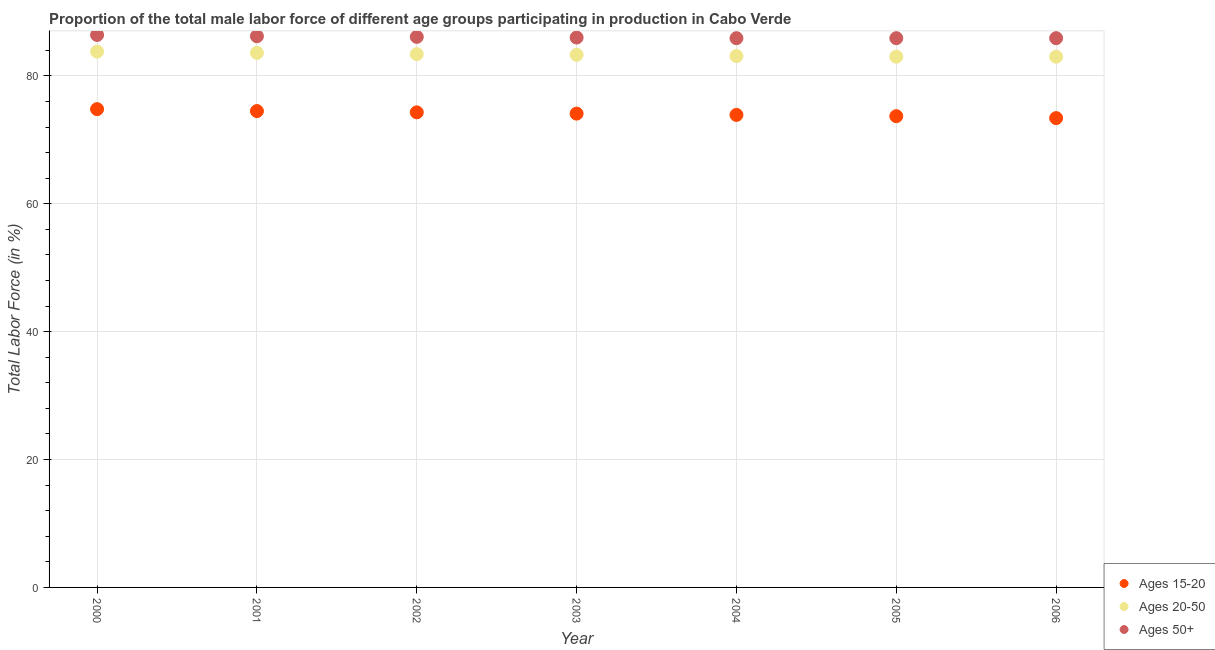What is the percentage of male labor force within the age group 20-50 in 2002?
Your answer should be very brief. 83.4. Across all years, what is the maximum percentage of male labor force above age 50?
Make the answer very short. 86.4. Across all years, what is the minimum percentage of male labor force within the age group 15-20?
Provide a succinct answer. 73.4. In which year was the percentage of male labor force above age 50 maximum?
Provide a short and direct response. 2000. In which year was the percentage of male labor force within the age group 20-50 minimum?
Offer a terse response. 2005. What is the total percentage of male labor force within the age group 20-50 in the graph?
Provide a short and direct response. 583.2. What is the difference between the percentage of male labor force above age 50 in 2003 and that in 2004?
Your response must be concise. 0.1. What is the difference between the percentage of male labor force above age 50 in 2003 and the percentage of male labor force within the age group 20-50 in 2004?
Give a very brief answer. 2.9. What is the average percentage of male labor force within the age group 20-50 per year?
Provide a succinct answer. 83.31. In the year 2006, what is the difference between the percentage of male labor force within the age group 15-20 and percentage of male labor force within the age group 20-50?
Offer a very short reply. -9.6. What is the ratio of the percentage of male labor force within the age group 15-20 in 2001 to that in 2004?
Your answer should be very brief. 1.01. Is the percentage of male labor force above age 50 in 2003 less than that in 2006?
Provide a succinct answer. No. Is the difference between the percentage of male labor force within the age group 15-20 in 2002 and 2003 greater than the difference between the percentage of male labor force within the age group 20-50 in 2002 and 2003?
Provide a short and direct response. Yes. What is the difference between the highest and the second highest percentage of male labor force within the age group 20-50?
Offer a terse response. 0.2. What is the difference between the highest and the lowest percentage of male labor force within the age group 15-20?
Provide a short and direct response. 1.4. Is the sum of the percentage of male labor force above age 50 in 2001 and 2004 greater than the maximum percentage of male labor force within the age group 20-50 across all years?
Your answer should be very brief. Yes. Is it the case that in every year, the sum of the percentage of male labor force within the age group 15-20 and percentage of male labor force within the age group 20-50 is greater than the percentage of male labor force above age 50?
Your response must be concise. Yes. How many dotlines are there?
Give a very brief answer. 3. How many years are there in the graph?
Provide a short and direct response. 7. What is the difference between two consecutive major ticks on the Y-axis?
Your answer should be very brief. 20. Where does the legend appear in the graph?
Keep it short and to the point. Bottom right. How are the legend labels stacked?
Provide a succinct answer. Vertical. What is the title of the graph?
Give a very brief answer. Proportion of the total male labor force of different age groups participating in production in Cabo Verde. Does "Solid fuel" appear as one of the legend labels in the graph?
Offer a terse response. No. What is the label or title of the Y-axis?
Provide a succinct answer. Total Labor Force (in %). What is the Total Labor Force (in %) of Ages 15-20 in 2000?
Ensure brevity in your answer.  74.8. What is the Total Labor Force (in %) in Ages 20-50 in 2000?
Provide a succinct answer. 83.8. What is the Total Labor Force (in %) in Ages 50+ in 2000?
Make the answer very short. 86.4. What is the Total Labor Force (in %) in Ages 15-20 in 2001?
Your answer should be very brief. 74.5. What is the Total Labor Force (in %) of Ages 20-50 in 2001?
Give a very brief answer. 83.6. What is the Total Labor Force (in %) of Ages 50+ in 2001?
Your response must be concise. 86.2. What is the Total Labor Force (in %) in Ages 15-20 in 2002?
Keep it short and to the point. 74.3. What is the Total Labor Force (in %) in Ages 20-50 in 2002?
Offer a terse response. 83.4. What is the Total Labor Force (in %) of Ages 50+ in 2002?
Provide a succinct answer. 86.1. What is the Total Labor Force (in %) in Ages 15-20 in 2003?
Give a very brief answer. 74.1. What is the Total Labor Force (in %) of Ages 20-50 in 2003?
Give a very brief answer. 83.3. What is the Total Labor Force (in %) in Ages 15-20 in 2004?
Offer a very short reply. 73.9. What is the Total Labor Force (in %) of Ages 20-50 in 2004?
Your answer should be compact. 83.1. What is the Total Labor Force (in %) of Ages 50+ in 2004?
Your answer should be very brief. 85.9. What is the Total Labor Force (in %) in Ages 15-20 in 2005?
Make the answer very short. 73.7. What is the Total Labor Force (in %) of Ages 20-50 in 2005?
Your answer should be compact. 83. What is the Total Labor Force (in %) of Ages 50+ in 2005?
Keep it short and to the point. 85.9. What is the Total Labor Force (in %) of Ages 15-20 in 2006?
Provide a succinct answer. 73.4. What is the Total Labor Force (in %) of Ages 20-50 in 2006?
Provide a succinct answer. 83. What is the Total Labor Force (in %) of Ages 50+ in 2006?
Your answer should be very brief. 85.9. Across all years, what is the maximum Total Labor Force (in %) of Ages 15-20?
Your response must be concise. 74.8. Across all years, what is the maximum Total Labor Force (in %) of Ages 20-50?
Your answer should be very brief. 83.8. Across all years, what is the maximum Total Labor Force (in %) of Ages 50+?
Provide a short and direct response. 86.4. Across all years, what is the minimum Total Labor Force (in %) of Ages 15-20?
Your answer should be very brief. 73.4. Across all years, what is the minimum Total Labor Force (in %) in Ages 20-50?
Your response must be concise. 83. Across all years, what is the minimum Total Labor Force (in %) in Ages 50+?
Your response must be concise. 85.9. What is the total Total Labor Force (in %) in Ages 15-20 in the graph?
Offer a terse response. 518.7. What is the total Total Labor Force (in %) of Ages 20-50 in the graph?
Offer a very short reply. 583.2. What is the total Total Labor Force (in %) of Ages 50+ in the graph?
Your answer should be compact. 602.4. What is the difference between the Total Labor Force (in %) of Ages 50+ in 2000 and that in 2001?
Make the answer very short. 0.2. What is the difference between the Total Labor Force (in %) in Ages 20-50 in 2000 and that in 2004?
Provide a succinct answer. 0.7. What is the difference between the Total Labor Force (in %) of Ages 50+ in 2000 and that in 2004?
Offer a very short reply. 0.5. What is the difference between the Total Labor Force (in %) in Ages 50+ in 2000 and that in 2005?
Offer a very short reply. 0.5. What is the difference between the Total Labor Force (in %) of Ages 20-50 in 2000 and that in 2006?
Provide a succinct answer. 0.8. What is the difference between the Total Labor Force (in %) in Ages 50+ in 2000 and that in 2006?
Your answer should be very brief. 0.5. What is the difference between the Total Labor Force (in %) of Ages 15-20 in 2001 and that in 2002?
Keep it short and to the point. 0.2. What is the difference between the Total Labor Force (in %) of Ages 20-50 in 2001 and that in 2002?
Provide a succinct answer. 0.2. What is the difference between the Total Labor Force (in %) in Ages 50+ in 2001 and that in 2002?
Your response must be concise. 0.1. What is the difference between the Total Labor Force (in %) of Ages 15-20 in 2001 and that in 2004?
Provide a short and direct response. 0.6. What is the difference between the Total Labor Force (in %) of Ages 50+ in 2001 and that in 2004?
Ensure brevity in your answer.  0.3. What is the difference between the Total Labor Force (in %) in Ages 15-20 in 2001 and that in 2006?
Keep it short and to the point. 1.1. What is the difference between the Total Labor Force (in %) in Ages 50+ in 2002 and that in 2003?
Keep it short and to the point. 0.1. What is the difference between the Total Labor Force (in %) of Ages 15-20 in 2002 and that in 2005?
Your answer should be compact. 0.6. What is the difference between the Total Labor Force (in %) of Ages 50+ in 2002 and that in 2005?
Make the answer very short. 0.2. What is the difference between the Total Labor Force (in %) of Ages 20-50 in 2002 and that in 2006?
Your answer should be compact. 0.4. What is the difference between the Total Labor Force (in %) in Ages 50+ in 2002 and that in 2006?
Provide a short and direct response. 0.2. What is the difference between the Total Labor Force (in %) of Ages 50+ in 2003 and that in 2004?
Your answer should be compact. 0.1. What is the difference between the Total Labor Force (in %) of Ages 50+ in 2003 and that in 2005?
Ensure brevity in your answer.  0.1. What is the difference between the Total Labor Force (in %) of Ages 15-20 in 2003 and that in 2006?
Your answer should be compact. 0.7. What is the difference between the Total Labor Force (in %) of Ages 50+ in 2004 and that in 2005?
Your answer should be compact. 0. What is the difference between the Total Labor Force (in %) of Ages 15-20 in 2004 and that in 2006?
Offer a terse response. 0.5. What is the difference between the Total Labor Force (in %) in Ages 20-50 in 2004 and that in 2006?
Your answer should be very brief. 0.1. What is the difference between the Total Labor Force (in %) in Ages 50+ in 2004 and that in 2006?
Ensure brevity in your answer.  0. What is the difference between the Total Labor Force (in %) in Ages 15-20 in 2005 and that in 2006?
Offer a very short reply. 0.3. What is the difference between the Total Labor Force (in %) of Ages 50+ in 2005 and that in 2006?
Your answer should be compact. 0. What is the difference between the Total Labor Force (in %) in Ages 15-20 in 2000 and the Total Labor Force (in %) in Ages 20-50 in 2001?
Provide a short and direct response. -8.8. What is the difference between the Total Labor Force (in %) in Ages 15-20 in 2000 and the Total Labor Force (in %) in Ages 50+ in 2001?
Keep it short and to the point. -11.4. What is the difference between the Total Labor Force (in %) in Ages 15-20 in 2000 and the Total Labor Force (in %) in Ages 20-50 in 2002?
Offer a very short reply. -8.6. What is the difference between the Total Labor Force (in %) of Ages 15-20 in 2000 and the Total Labor Force (in %) of Ages 50+ in 2002?
Offer a terse response. -11.3. What is the difference between the Total Labor Force (in %) in Ages 15-20 in 2000 and the Total Labor Force (in %) in Ages 50+ in 2003?
Offer a terse response. -11.2. What is the difference between the Total Labor Force (in %) of Ages 20-50 in 2000 and the Total Labor Force (in %) of Ages 50+ in 2003?
Keep it short and to the point. -2.2. What is the difference between the Total Labor Force (in %) in Ages 20-50 in 2000 and the Total Labor Force (in %) in Ages 50+ in 2004?
Your response must be concise. -2.1. What is the difference between the Total Labor Force (in %) of Ages 15-20 in 2000 and the Total Labor Force (in %) of Ages 20-50 in 2005?
Provide a short and direct response. -8.2. What is the difference between the Total Labor Force (in %) in Ages 15-20 in 2000 and the Total Labor Force (in %) in Ages 50+ in 2005?
Your response must be concise. -11.1. What is the difference between the Total Labor Force (in %) in Ages 15-20 in 2000 and the Total Labor Force (in %) in Ages 20-50 in 2006?
Your answer should be compact. -8.2. What is the difference between the Total Labor Force (in %) of Ages 15-20 in 2000 and the Total Labor Force (in %) of Ages 50+ in 2006?
Ensure brevity in your answer.  -11.1. What is the difference between the Total Labor Force (in %) of Ages 15-20 in 2001 and the Total Labor Force (in %) of Ages 50+ in 2002?
Provide a succinct answer. -11.6. What is the difference between the Total Labor Force (in %) of Ages 20-50 in 2001 and the Total Labor Force (in %) of Ages 50+ in 2002?
Keep it short and to the point. -2.5. What is the difference between the Total Labor Force (in %) of Ages 15-20 in 2001 and the Total Labor Force (in %) of Ages 50+ in 2003?
Make the answer very short. -11.5. What is the difference between the Total Labor Force (in %) in Ages 15-20 in 2001 and the Total Labor Force (in %) in Ages 50+ in 2004?
Your answer should be compact. -11.4. What is the difference between the Total Labor Force (in %) in Ages 20-50 in 2001 and the Total Labor Force (in %) in Ages 50+ in 2004?
Ensure brevity in your answer.  -2.3. What is the difference between the Total Labor Force (in %) in Ages 15-20 in 2001 and the Total Labor Force (in %) in Ages 20-50 in 2005?
Give a very brief answer. -8.5. What is the difference between the Total Labor Force (in %) in Ages 15-20 in 2001 and the Total Labor Force (in %) in Ages 50+ in 2005?
Make the answer very short. -11.4. What is the difference between the Total Labor Force (in %) of Ages 20-50 in 2001 and the Total Labor Force (in %) of Ages 50+ in 2005?
Keep it short and to the point. -2.3. What is the difference between the Total Labor Force (in %) of Ages 15-20 in 2001 and the Total Labor Force (in %) of Ages 20-50 in 2006?
Your answer should be compact. -8.5. What is the difference between the Total Labor Force (in %) of Ages 15-20 in 2001 and the Total Labor Force (in %) of Ages 50+ in 2006?
Keep it short and to the point. -11.4. What is the difference between the Total Labor Force (in %) of Ages 20-50 in 2001 and the Total Labor Force (in %) of Ages 50+ in 2006?
Make the answer very short. -2.3. What is the difference between the Total Labor Force (in %) of Ages 15-20 in 2002 and the Total Labor Force (in %) of Ages 20-50 in 2003?
Provide a succinct answer. -9. What is the difference between the Total Labor Force (in %) in Ages 15-20 in 2002 and the Total Labor Force (in %) in Ages 50+ in 2003?
Your response must be concise. -11.7. What is the difference between the Total Labor Force (in %) in Ages 20-50 in 2002 and the Total Labor Force (in %) in Ages 50+ in 2003?
Provide a short and direct response. -2.6. What is the difference between the Total Labor Force (in %) of Ages 15-20 in 2002 and the Total Labor Force (in %) of Ages 50+ in 2004?
Make the answer very short. -11.6. What is the difference between the Total Labor Force (in %) of Ages 15-20 in 2002 and the Total Labor Force (in %) of Ages 20-50 in 2005?
Your response must be concise. -8.7. What is the difference between the Total Labor Force (in %) in Ages 15-20 in 2002 and the Total Labor Force (in %) in Ages 50+ in 2005?
Your answer should be compact. -11.6. What is the difference between the Total Labor Force (in %) in Ages 20-50 in 2002 and the Total Labor Force (in %) in Ages 50+ in 2005?
Ensure brevity in your answer.  -2.5. What is the difference between the Total Labor Force (in %) of Ages 15-20 in 2002 and the Total Labor Force (in %) of Ages 20-50 in 2006?
Make the answer very short. -8.7. What is the difference between the Total Labor Force (in %) of Ages 15-20 in 2003 and the Total Labor Force (in %) of Ages 50+ in 2004?
Ensure brevity in your answer.  -11.8. What is the difference between the Total Labor Force (in %) in Ages 20-50 in 2003 and the Total Labor Force (in %) in Ages 50+ in 2005?
Make the answer very short. -2.6. What is the difference between the Total Labor Force (in %) of Ages 15-20 in 2003 and the Total Labor Force (in %) of Ages 20-50 in 2006?
Provide a succinct answer. -8.9. What is the difference between the Total Labor Force (in %) in Ages 15-20 in 2003 and the Total Labor Force (in %) in Ages 50+ in 2006?
Keep it short and to the point. -11.8. What is the difference between the Total Labor Force (in %) in Ages 15-20 in 2004 and the Total Labor Force (in %) in Ages 20-50 in 2005?
Your answer should be compact. -9.1. What is the difference between the Total Labor Force (in %) in Ages 15-20 in 2004 and the Total Labor Force (in %) in Ages 50+ in 2005?
Provide a short and direct response. -12. What is the difference between the Total Labor Force (in %) of Ages 15-20 in 2004 and the Total Labor Force (in %) of Ages 50+ in 2006?
Give a very brief answer. -12. What is the difference between the Total Labor Force (in %) of Ages 15-20 in 2005 and the Total Labor Force (in %) of Ages 20-50 in 2006?
Give a very brief answer. -9.3. What is the difference between the Total Labor Force (in %) in Ages 15-20 in 2005 and the Total Labor Force (in %) in Ages 50+ in 2006?
Keep it short and to the point. -12.2. What is the average Total Labor Force (in %) in Ages 15-20 per year?
Give a very brief answer. 74.1. What is the average Total Labor Force (in %) in Ages 20-50 per year?
Keep it short and to the point. 83.31. What is the average Total Labor Force (in %) of Ages 50+ per year?
Your answer should be compact. 86.06. In the year 2000, what is the difference between the Total Labor Force (in %) of Ages 15-20 and Total Labor Force (in %) of Ages 20-50?
Offer a very short reply. -9. In the year 2000, what is the difference between the Total Labor Force (in %) in Ages 15-20 and Total Labor Force (in %) in Ages 50+?
Your answer should be very brief. -11.6. In the year 2001, what is the difference between the Total Labor Force (in %) of Ages 15-20 and Total Labor Force (in %) of Ages 20-50?
Your response must be concise. -9.1. In the year 2001, what is the difference between the Total Labor Force (in %) of Ages 20-50 and Total Labor Force (in %) of Ages 50+?
Your response must be concise. -2.6. In the year 2002, what is the difference between the Total Labor Force (in %) of Ages 20-50 and Total Labor Force (in %) of Ages 50+?
Provide a short and direct response. -2.7. In the year 2003, what is the difference between the Total Labor Force (in %) in Ages 15-20 and Total Labor Force (in %) in Ages 20-50?
Your response must be concise. -9.2. In the year 2004, what is the difference between the Total Labor Force (in %) of Ages 20-50 and Total Labor Force (in %) of Ages 50+?
Offer a terse response. -2.8. In the year 2006, what is the difference between the Total Labor Force (in %) of Ages 15-20 and Total Labor Force (in %) of Ages 20-50?
Your answer should be compact. -9.6. In the year 2006, what is the difference between the Total Labor Force (in %) in Ages 15-20 and Total Labor Force (in %) in Ages 50+?
Your answer should be very brief. -12.5. What is the ratio of the Total Labor Force (in %) of Ages 15-20 in 2000 to that in 2001?
Your response must be concise. 1. What is the ratio of the Total Labor Force (in %) in Ages 20-50 in 2000 to that in 2001?
Make the answer very short. 1. What is the ratio of the Total Labor Force (in %) of Ages 15-20 in 2000 to that in 2002?
Provide a succinct answer. 1.01. What is the ratio of the Total Labor Force (in %) in Ages 50+ in 2000 to that in 2002?
Make the answer very short. 1. What is the ratio of the Total Labor Force (in %) of Ages 15-20 in 2000 to that in 2003?
Offer a very short reply. 1.01. What is the ratio of the Total Labor Force (in %) of Ages 20-50 in 2000 to that in 2003?
Provide a short and direct response. 1.01. What is the ratio of the Total Labor Force (in %) of Ages 50+ in 2000 to that in 2003?
Offer a terse response. 1. What is the ratio of the Total Labor Force (in %) in Ages 15-20 in 2000 to that in 2004?
Give a very brief answer. 1.01. What is the ratio of the Total Labor Force (in %) in Ages 20-50 in 2000 to that in 2004?
Keep it short and to the point. 1.01. What is the ratio of the Total Labor Force (in %) of Ages 50+ in 2000 to that in 2004?
Your answer should be compact. 1.01. What is the ratio of the Total Labor Force (in %) of Ages 15-20 in 2000 to that in 2005?
Provide a short and direct response. 1.01. What is the ratio of the Total Labor Force (in %) in Ages 20-50 in 2000 to that in 2005?
Ensure brevity in your answer.  1.01. What is the ratio of the Total Labor Force (in %) in Ages 15-20 in 2000 to that in 2006?
Provide a succinct answer. 1.02. What is the ratio of the Total Labor Force (in %) in Ages 20-50 in 2000 to that in 2006?
Your answer should be compact. 1.01. What is the ratio of the Total Labor Force (in %) in Ages 15-20 in 2001 to that in 2002?
Your response must be concise. 1. What is the ratio of the Total Labor Force (in %) in Ages 15-20 in 2001 to that in 2003?
Ensure brevity in your answer.  1.01. What is the ratio of the Total Labor Force (in %) of Ages 15-20 in 2001 to that in 2004?
Give a very brief answer. 1.01. What is the ratio of the Total Labor Force (in %) of Ages 20-50 in 2001 to that in 2004?
Your answer should be compact. 1.01. What is the ratio of the Total Labor Force (in %) in Ages 50+ in 2001 to that in 2004?
Provide a succinct answer. 1. What is the ratio of the Total Labor Force (in %) in Ages 15-20 in 2001 to that in 2005?
Keep it short and to the point. 1.01. What is the ratio of the Total Labor Force (in %) in Ages 20-50 in 2001 to that in 2005?
Provide a succinct answer. 1.01. What is the ratio of the Total Labor Force (in %) of Ages 50+ in 2001 to that in 2005?
Provide a succinct answer. 1. What is the ratio of the Total Labor Force (in %) in Ages 15-20 in 2001 to that in 2006?
Provide a short and direct response. 1.01. What is the ratio of the Total Labor Force (in %) of Ages 20-50 in 2001 to that in 2006?
Offer a terse response. 1.01. What is the ratio of the Total Labor Force (in %) in Ages 50+ in 2001 to that in 2006?
Your answer should be very brief. 1. What is the ratio of the Total Labor Force (in %) in Ages 50+ in 2002 to that in 2003?
Your answer should be very brief. 1. What is the ratio of the Total Labor Force (in %) of Ages 15-20 in 2002 to that in 2004?
Offer a very short reply. 1.01. What is the ratio of the Total Labor Force (in %) in Ages 50+ in 2002 to that in 2004?
Your response must be concise. 1. What is the ratio of the Total Labor Force (in %) of Ages 50+ in 2002 to that in 2005?
Make the answer very short. 1. What is the ratio of the Total Labor Force (in %) of Ages 15-20 in 2002 to that in 2006?
Offer a terse response. 1.01. What is the ratio of the Total Labor Force (in %) in Ages 15-20 in 2003 to that in 2004?
Offer a very short reply. 1. What is the ratio of the Total Labor Force (in %) in Ages 20-50 in 2003 to that in 2004?
Make the answer very short. 1. What is the ratio of the Total Labor Force (in %) in Ages 50+ in 2003 to that in 2004?
Your response must be concise. 1. What is the ratio of the Total Labor Force (in %) of Ages 15-20 in 2003 to that in 2005?
Provide a succinct answer. 1.01. What is the ratio of the Total Labor Force (in %) of Ages 15-20 in 2003 to that in 2006?
Keep it short and to the point. 1.01. What is the ratio of the Total Labor Force (in %) of Ages 20-50 in 2004 to that in 2005?
Offer a very short reply. 1. What is the ratio of the Total Labor Force (in %) of Ages 15-20 in 2004 to that in 2006?
Offer a terse response. 1.01. What is the ratio of the Total Labor Force (in %) in Ages 20-50 in 2004 to that in 2006?
Provide a short and direct response. 1. What is the ratio of the Total Labor Force (in %) of Ages 15-20 in 2005 to that in 2006?
Ensure brevity in your answer.  1. What is the ratio of the Total Labor Force (in %) in Ages 50+ in 2005 to that in 2006?
Provide a short and direct response. 1. What is the difference between the highest and the second highest Total Labor Force (in %) of Ages 15-20?
Provide a short and direct response. 0.3. What is the difference between the highest and the lowest Total Labor Force (in %) in Ages 15-20?
Offer a terse response. 1.4. What is the difference between the highest and the lowest Total Labor Force (in %) of Ages 20-50?
Provide a succinct answer. 0.8. 